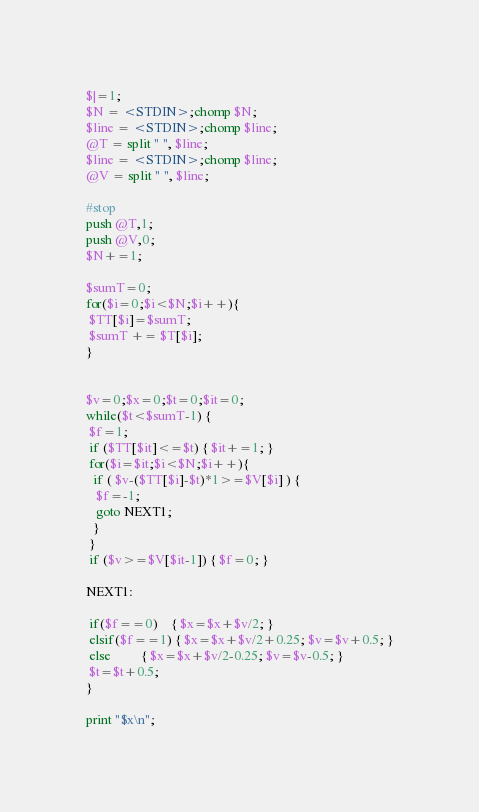<code> <loc_0><loc_0><loc_500><loc_500><_Perl_>$|=1;
$N = <STDIN>;chomp $N;
$line = <STDIN>;chomp $line;
@T = split " ", $line;
$line = <STDIN>;chomp $line;
@V = split " ", $line;

#stop
push @T,1;
push @V,0;
$N+=1;

$sumT=0;
for($i=0;$i<$N;$i++){
 $TT[$i]=$sumT;
 $sumT += $T[$i];
}


$v=0;$x=0;$t=0;$it=0;
while($t<$sumT-1) {
 $f=1;
 if ($TT[$it]<=$t) { $it+=1; }
 for($i=$it;$i<$N;$i++){
  if ( $v-($TT[$i]-$t)*1>=$V[$i] ) {
   $f=-1;
   goto NEXT1;
  }
 }
 if ($v>=$V[$it-1]) { $f=0; }
 
NEXT1:
 
 if($f==0)    { $x=$x+$v/2; }
 elsif($f==1) { $x=$x+$v/2+0.25; $v=$v+0.5; }
 else         { $x=$x+$v/2-0.25; $v=$v-0.5; }
 $t=$t+0.5;
}

print "$x\n";
</code> 